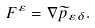<formula> <loc_0><loc_0><loc_500><loc_500>F ^ { \varepsilon } = \nabla \widetilde { p } _ { \varepsilon \delta } .</formula> 